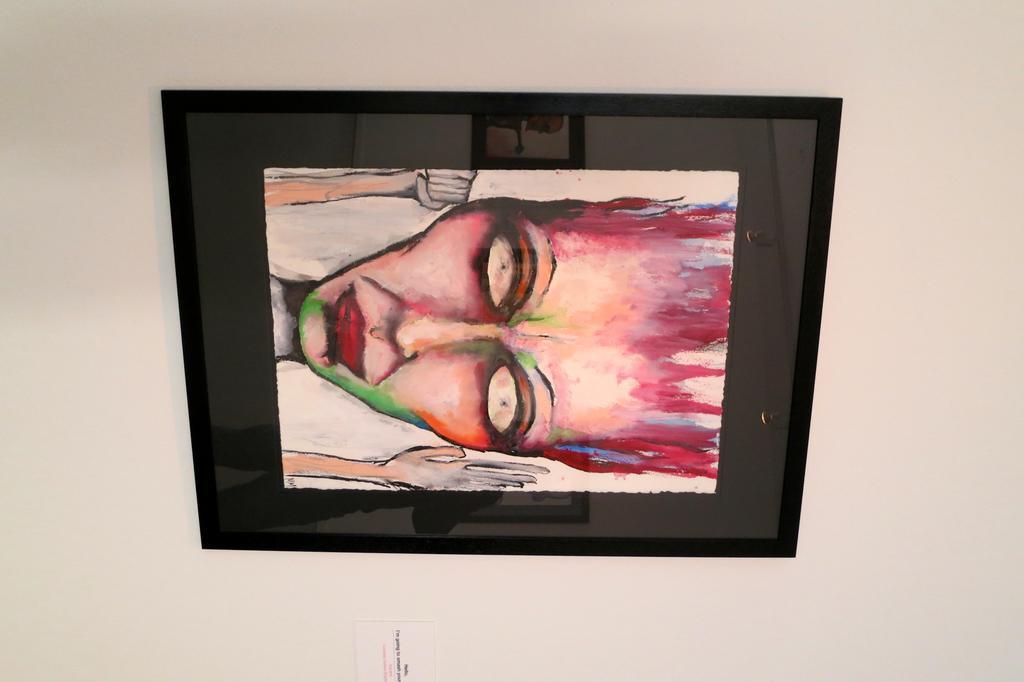Could you give a brief overview of what you see in this image? In this image there is a painting of a person, there is a photo frame, there is a card truncated towards the bottom of the image, there is text on the card, at the background of the image there is the wall truncated. 